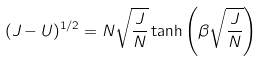Convert formula to latex. <formula><loc_0><loc_0><loc_500><loc_500>( J - U ) ^ { 1 / 2 } = N \sqrt { \frac { J } { N } } \tanh \left ( \beta \sqrt { \frac { J } { N } } \right )</formula> 